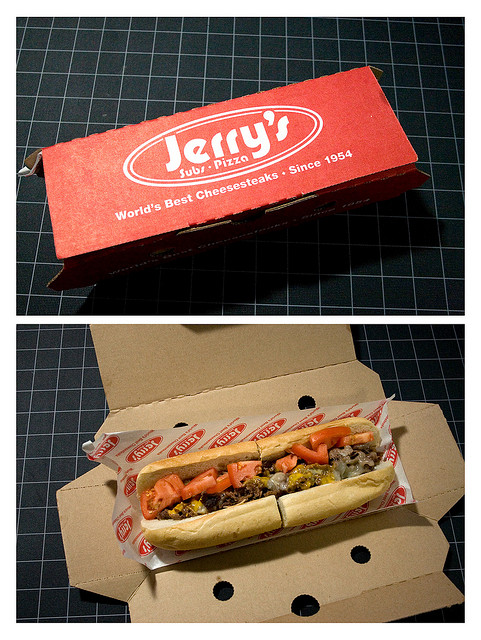Read and extract the text from this image. JERRY'S Sub Pizza World's Best Cheesesteaks Since 1954 Jerry's 